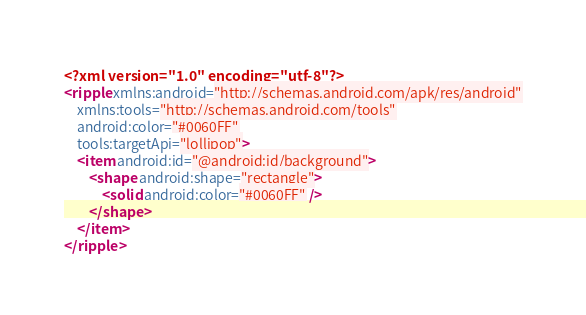Convert code to text. <code><loc_0><loc_0><loc_500><loc_500><_XML_><?xml version="1.0" encoding="utf-8"?>
<ripple xmlns:android="http://schemas.android.com/apk/res/android"
    xmlns:tools="http://schemas.android.com/tools"
    android:color="#0060FF"
    tools:targetApi="lollipop">
    <item android:id="@android:id/background">
        <shape android:shape="rectangle">
            <solid android:color="#0060FF" />
        </shape>
    </item>
</ripple></code> 